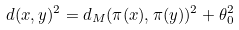Convert formula to latex. <formula><loc_0><loc_0><loc_500><loc_500>d ( x , y ) ^ { 2 } = d _ { M } ( \pi ( x ) , \pi ( y ) ) ^ { 2 } + \theta _ { 0 } ^ { 2 }</formula> 